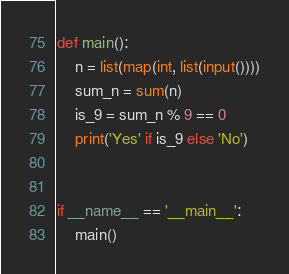Convert code to text. <code><loc_0><loc_0><loc_500><loc_500><_Python_>def main():
    n = list(map(int, list(input())))
    sum_n = sum(n)
    is_9 = sum_n % 9 == 0
    print('Yes' if is_9 else 'No')


if __name__ == '__main__':
    main()
</code> 